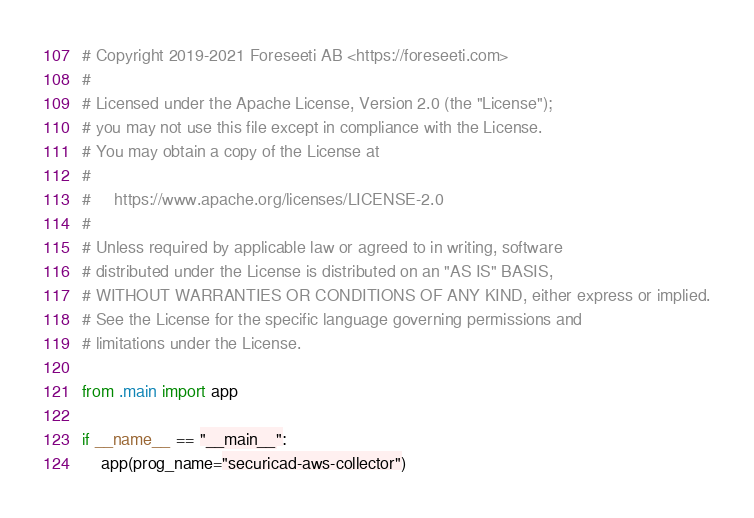<code> <loc_0><loc_0><loc_500><loc_500><_Python_># Copyright 2019-2021 Foreseeti AB <https://foreseeti.com>
#
# Licensed under the Apache License, Version 2.0 (the "License");
# you may not use this file except in compliance with the License.
# You may obtain a copy of the License at
#
#     https://www.apache.org/licenses/LICENSE-2.0
#
# Unless required by applicable law or agreed to in writing, software
# distributed under the License is distributed on an "AS IS" BASIS,
# WITHOUT WARRANTIES OR CONDITIONS OF ANY KIND, either express or implied.
# See the License for the specific language governing permissions and
# limitations under the License.

from .main import app

if __name__ == "__main__":
    app(prog_name="securicad-aws-collector")
</code> 